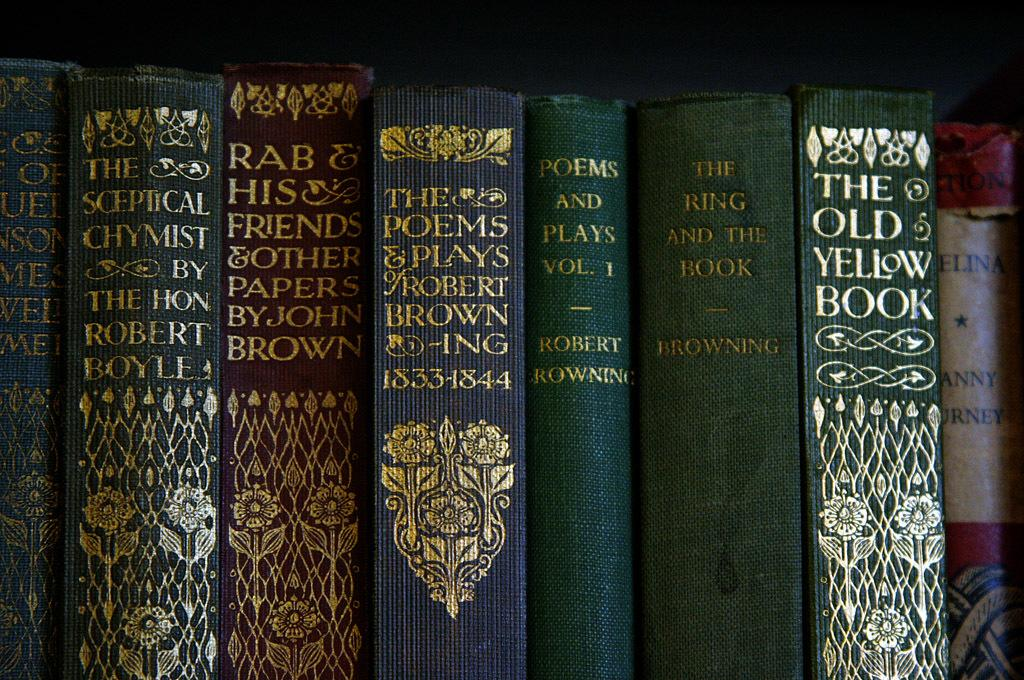<image>
Present a compact description of the photo's key features. Come by and read The Poems &Play by Robert Brown. 